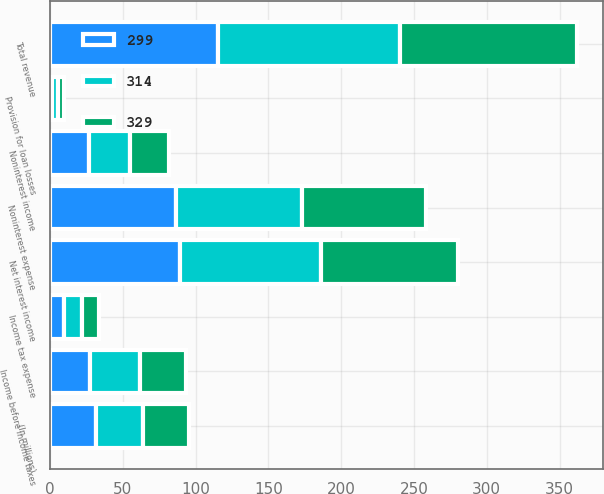<chart> <loc_0><loc_0><loc_500><loc_500><stacked_bar_chart><ecel><fcel>(In millions)<fcel>Net interest income<fcel>Noninterest income<fcel>Total revenue<fcel>Provision for loan losses<fcel>Noninterest expense<fcel>Income before income taxes<fcel>Income tax expense<nl><fcel>314<fcel>31.8<fcel>96.9<fcel>28.1<fcel>125<fcel>4<fcel>86.3<fcel>34.7<fcel>12.5<nl><fcel>329<fcel>31.8<fcel>94.2<fcel>26.8<fcel>121<fcel>4.2<fcel>85<fcel>31.8<fcel>11.7<nl><fcel>299<fcel>31.8<fcel>89.1<fcel>26.6<fcel>115.7<fcel>1.6<fcel>86.8<fcel>27.3<fcel>9.7<nl></chart> 